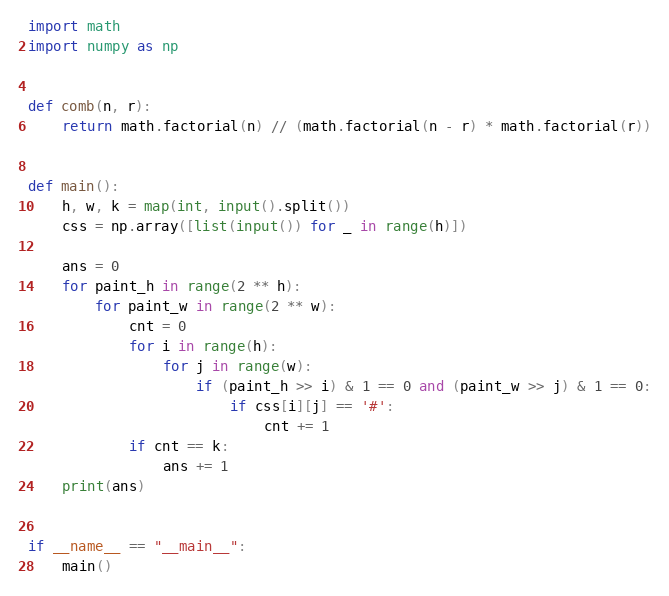Convert code to text. <code><loc_0><loc_0><loc_500><loc_500><_Python_>import math
import numpy as np


def comb(n, r):
    return math.factorial(n) // (math.factorial(n - r) * math.factorial(r))


def main():
    h, w, k = map(int, input().split())
    css = np.array([list(input()) for _ in range(h)])

    ans = 0
    for paint_h in range(2 ** h):
        for paint_w in range(2 ** w):
            cnt = 0
            for i in range(h):
                for j in range(w):
                    if (paint_h >> i) & 1 == 0 and (paint_w >> j) & 1 == 0:
                        if css[i][j] == '#':
                            cnt += 1
            if cnt == k:
                ans += 1
    print(ans)


if __name__ == "__main__":
    main()
</code> 